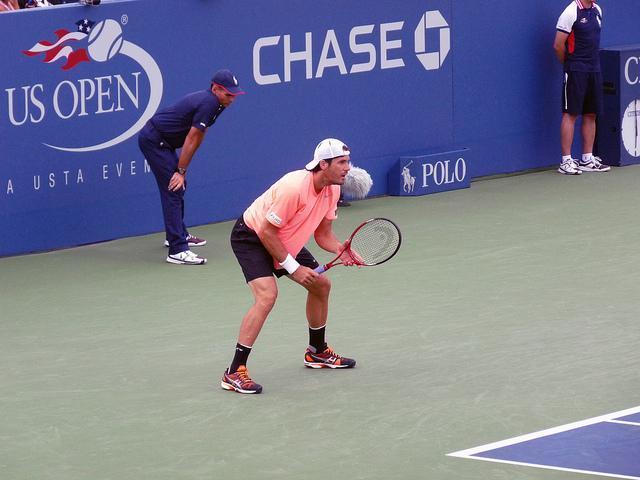How many people can be seen?
Give a very brief answer. 3. How many white cars are there?
Give a very brief answer. 0. 